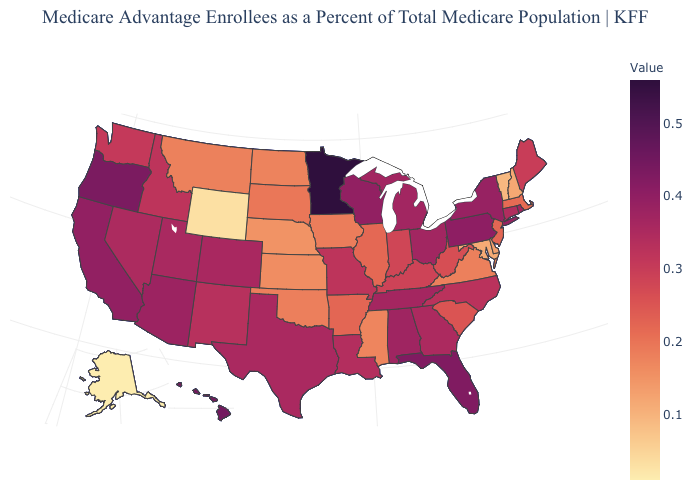Does Idaho have the highest value in the USA?
Concise answer only. No. Which states have the lowest value in the USA?
Keep it brief. Alaska. Which states have the lowest value in the Northeast?
Quick response, please. Vermont. Which states have the highest value in the USA?
Keep it brief. Minnesota. 